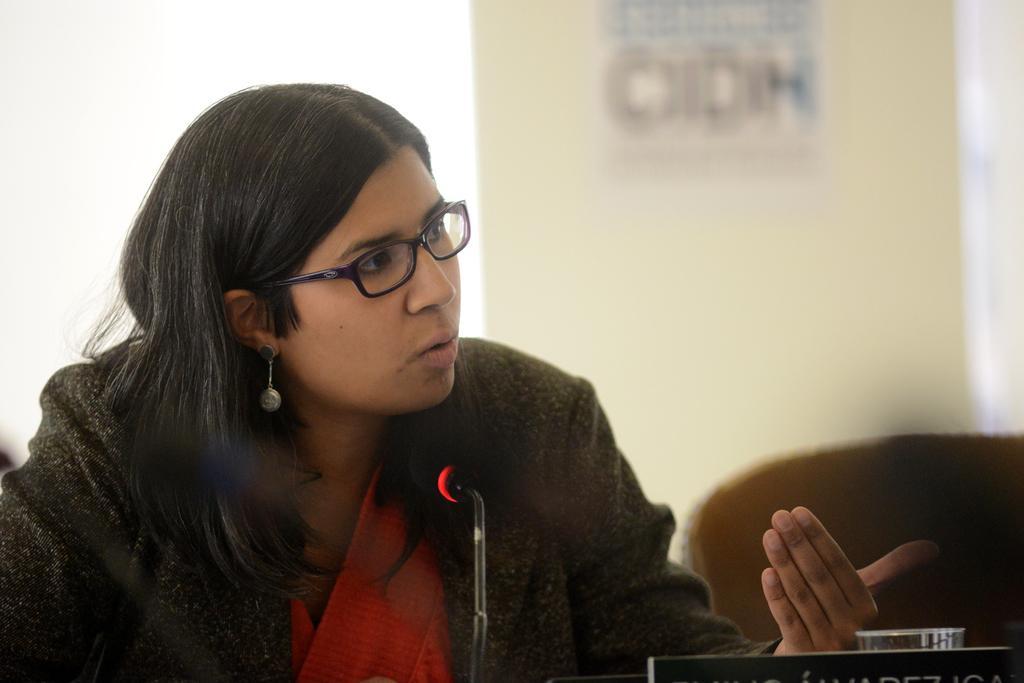In one or two sentences, can you explain what this image depicts? In this image we can see a woman and there is a microphone, glass and a name board at the bottom. In the background the image is blur but we can see object on the wall, window and other objects. 